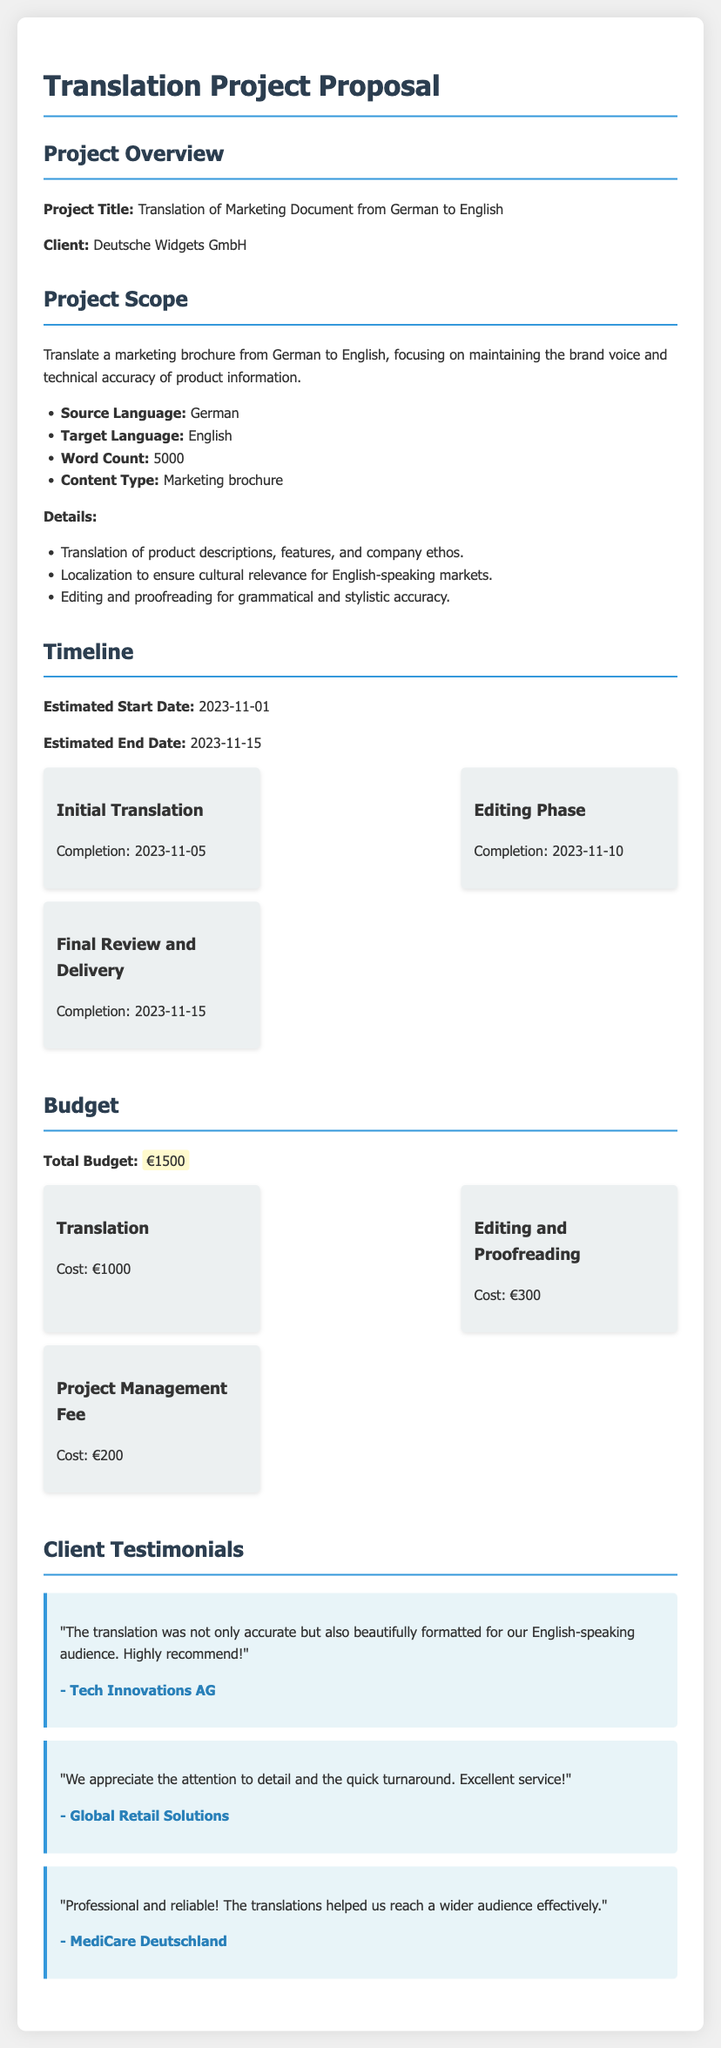What is the project title? The project title is stated in the project overview section, which describes the objective of the translation project.
Answer: Translation of Marketing Document from German to English What is the source language? The source language is specified under the project scope, indicating the language of the original document to be translated.
Answer: German What is the word count of the document? The word count is detailed in the project scope section, indicating the length of the text to be translated.
Answer: 5000 What is the completion date for the initial translation? The completion date for the initial translation is provided in the timeline, indicating when this phase will be finished.
Answer: 2023-11-05 What is the total budget for the project? The total budget is listed in the budget section, summarizing the financial allocation for the entire translation project.
Answer: €1500 How much does editing and proofreading cost? The cost of editing and proofreading is specified in the budget section, detailing expenses associated with these services.
Answer: €300 Who is the client for this project? The client is mentioned in the project overview section, identifying the organization requesting the translation service.
Answer: Deutsche Widgets GmbH What is a key detail in the project scope regarding translation? A key detail in the project scope outlines a specific focus that the translation must maintain during the process.
Answer: Maintaining the brand voice Which company provided a testimonial about the service? The testimonials section mentions clients who have expressed satisfaction with the translation services provided.
Answer: Tech Innovations AG What is the completion date for the final review and delivery? The completion date for the final review and delivery is clearly stated in the timeline, indicating when the project will be finalized and sent to the client.
Answer: 2023-11-15 